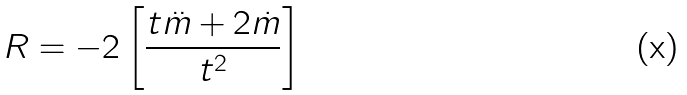<formula> <loc_0><loc_0><loc_500><loc_500>R = - 2 \left [ \frac { t \ddot { m } + 2 \dot { m } } { t ^ { 2 } } \right ]</formula> 